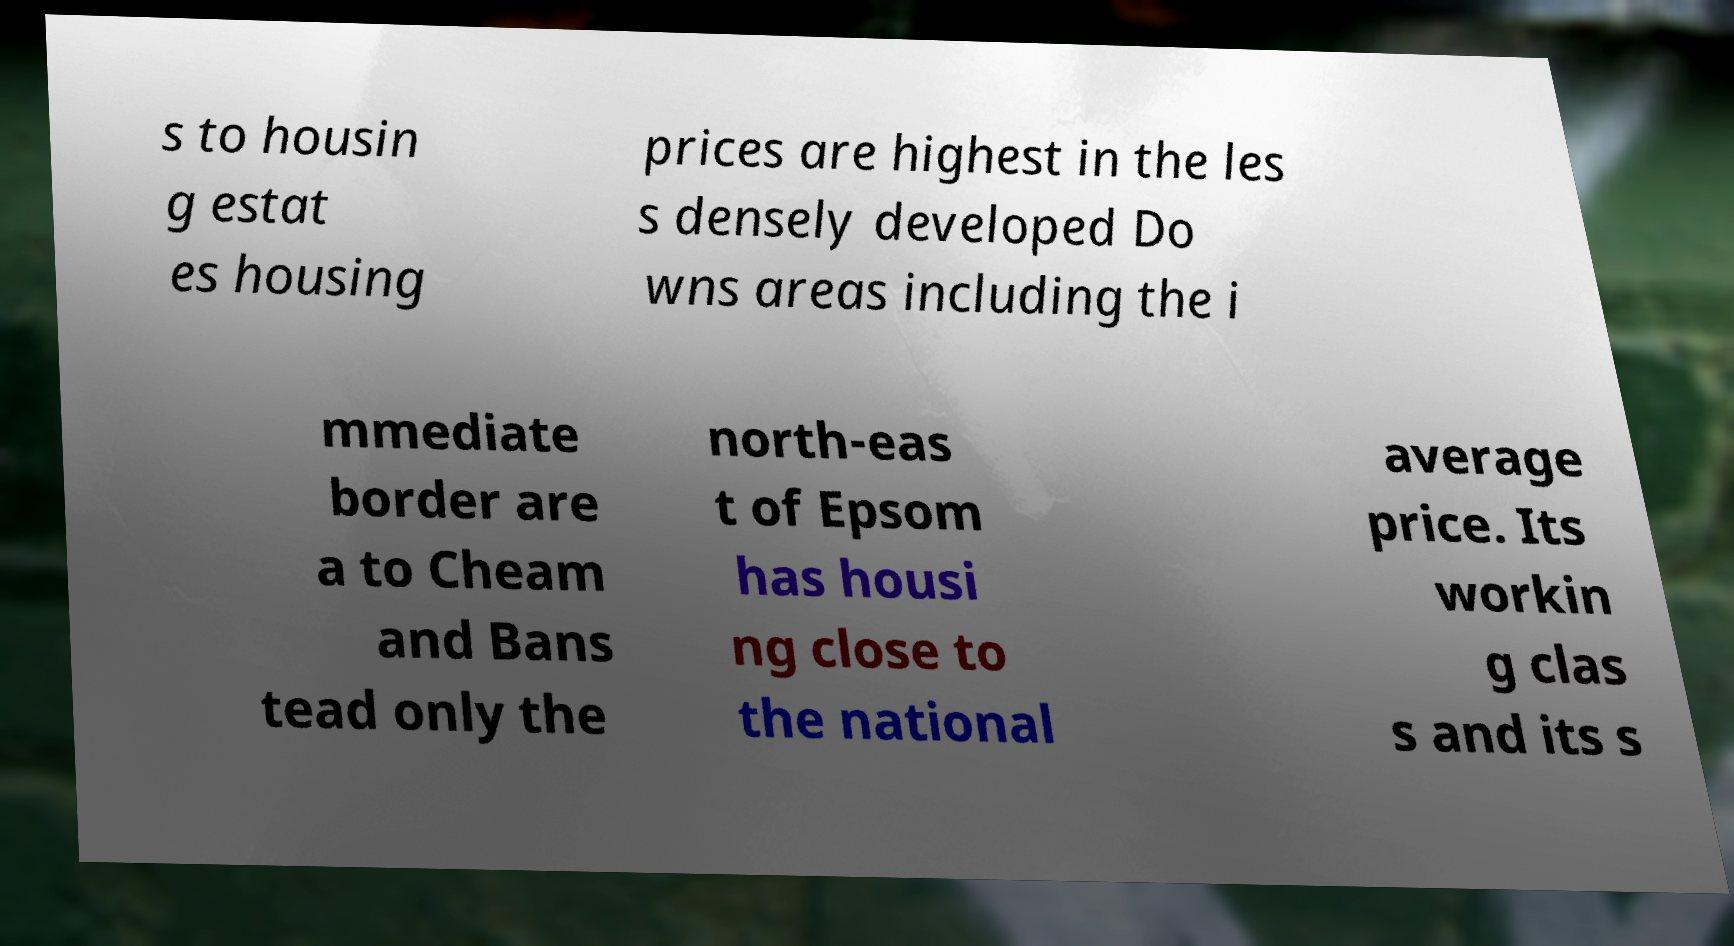Could you assist in decoding the text presented in this image and type it out clearly? s to housin g estat es housing prices are highest in the les s densely developed Do wns areas including the i mmediate border are a to Cheam and Bans tead only the north-eas t of Epsom has housi ng close to the national average price. Its workin g clas s and its s 